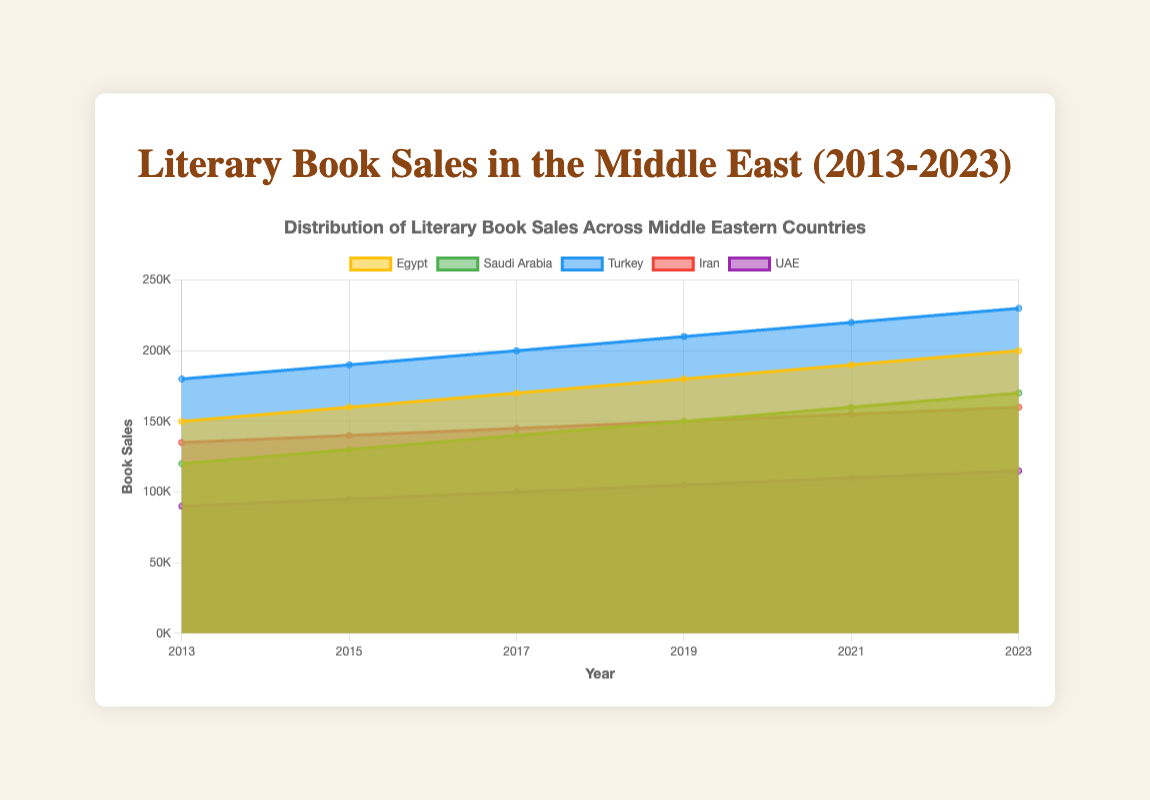Which country showed the highest increase in literary book sales from 2013 to 2023? To find this, compare the sales in 2013 and 2023 for each country. Egypt increased from 150,000 to 200,000, Saudi Arabia from 120,000 to 170,000, Turkey from 180,000 to 230,000, Iran from 135,000 to 160,000, and UAE from 90,000 to 115,000. The highest increase is for Turkey (50,000).
Answer: Turkey In which year did Egypt's literary book sales reach 180,000? Look at the sales figures for Egypt year by year. Egypt reached 180,000 sales in 2019.
Answer: 2019 Among the countries, which one had the lowest book sales in 2017? Compare the book sales of all countries in 2017: Egypt (170,000), Saudi Arabia (140,000), Turkey (200,000), Iran (145,000), UAE (100,000). The UAE had the lowest sales (100,000).
Answer: UAE What is the average literary book sales in Iran over the years provided? Add all the sales of Iran and divide by the number of years: (135,000 + 140,000 + 145,000 + 150,000 + 155,000 + 160,000) / 6 = 885,000 / 6 = 147,500.
Answer: 147,500 Did any country's sales ever decline compared to the previous recorded year? Examine the sales from year to year for each country. All countries show a steady increase without any declines in the years recorded.
Answer: No Which year recorded the highest total sales across all the countries? Sum the sales for all countries for each year and compare. 2013: (150,000 + 120,000 + 180,000 + 135,000 + 90,000) = 675,000, 2015: (160,000 + 130,000 + 190,000 + 140,000 + 95,000) = 715,000, 2017: (170,000 + 140,000 + 200,000 + 145,000 + 100,000) = 755,000, 2019: (180,000 + 150,000 + 210,000 + 150,000 + 105,000) = 795,000, 2021: (190,000 + 160,000 + 220,000 + 155,000 + 110,000) = 835,000, 2023: (200,000 + 170,000 + 230,000 + 160,000 + 115,000) = 875,000. The highest total sales are in 2023.
Answer: 2023 Compare the sales growth rates of Egypt and UAE from 2013 to 2023. Which country grew faster? Calculate the growth rate for each country: Egypt's sales grew from 150,000 to 200,000, a 33.33% increase [(200,000 - 150,000) / 150,000 * 100]. UAE's sales grew from 90,000 to 115,000, a 27.78% increase [(115,000 - 90,000) / 90,000 * 100]. Egypt's growth rate is faster.
Answer: Egypt What is the approximate total literary book sales in Saudi Arabia over the decade? Sum the sales from each year for Saudi Arabia: 120,000 + 130,000 + 140,000 + 150,000 + 160,000 + 170,000 = 870,000.
Answer: 870,000 What is the percentage increase in literary book sales for Turkey from 2019 to 2023? Calculate the percentage increase: [(230,000 - 210,000) / 210,000 * 100] = 9.52%.
Answer: 9.52% Which country consistently had the highest literary book sales during the period? Compare the sales for each year. Turkey had the highest sales every year.
Answer: Turkey 